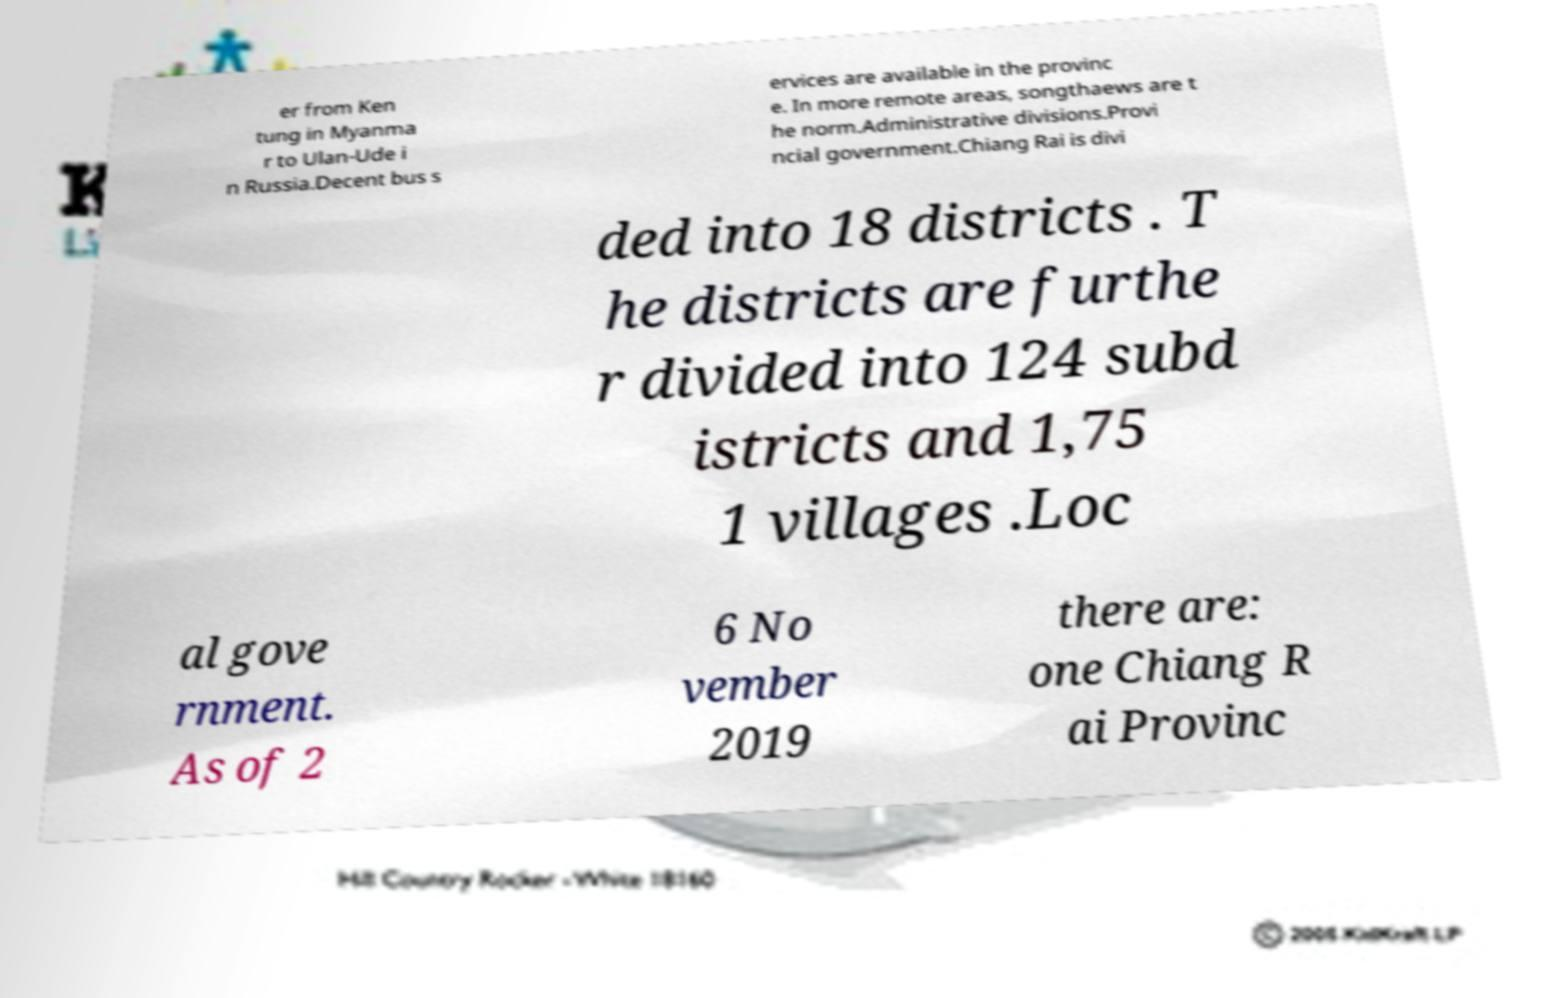Could you assist in decoding the text presented in this image and type it out clearly? er from Ken tung in Myanma r to Ulan-Ude i n Russia.Decent bus s ervices are available in the provinc e. In more remote areas, songthaews are t he norm.Administrative divisions.Provi ncial government.Chiang Rai is divi ded into 18 districts . T he districts are furthe r divided into 124 subd istricts and 1,75 1 villages .Loc al gove rnment. As of 2 6 No vember 2019 there are: one Chiang R ai Provinc 